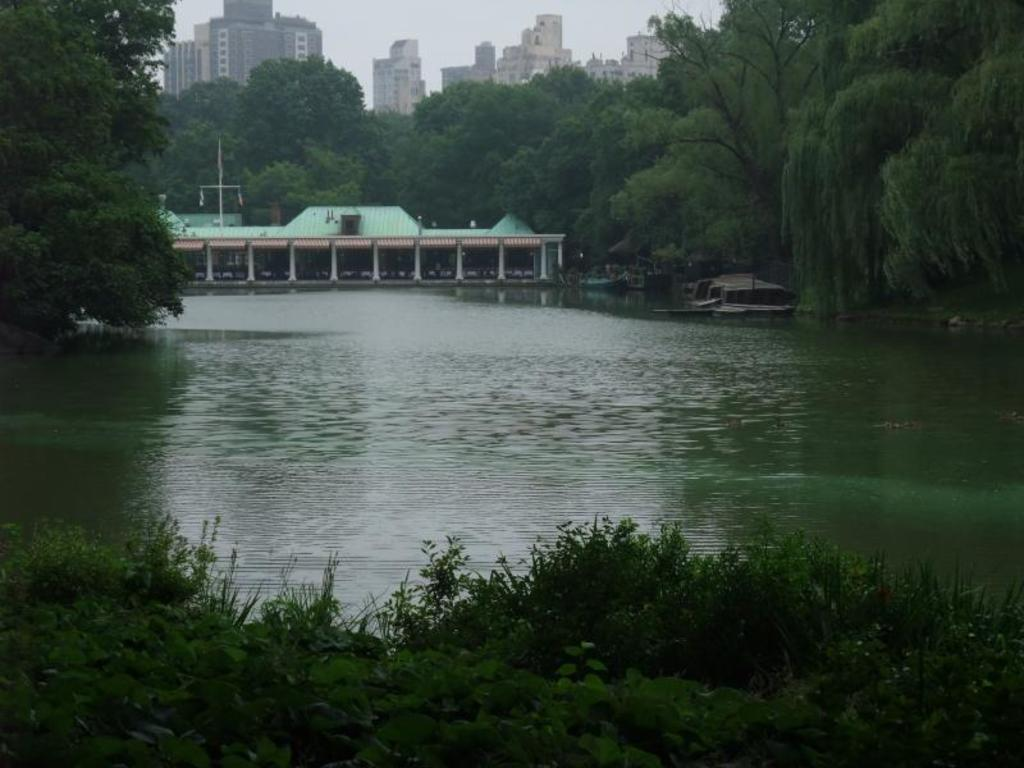What is the primary element present in the image? There is water in the image. What other natural elements can be seen in the image? There are plants in the image. What can be seen in the background of the image? There are trees and buildings in the background of the image. What part of the natural environment is visible in the image? The sky is visible in the image. What type of scarf is being used to support the tree in the image? There is no scarf present in the image, and no support is being provided to the tree. 